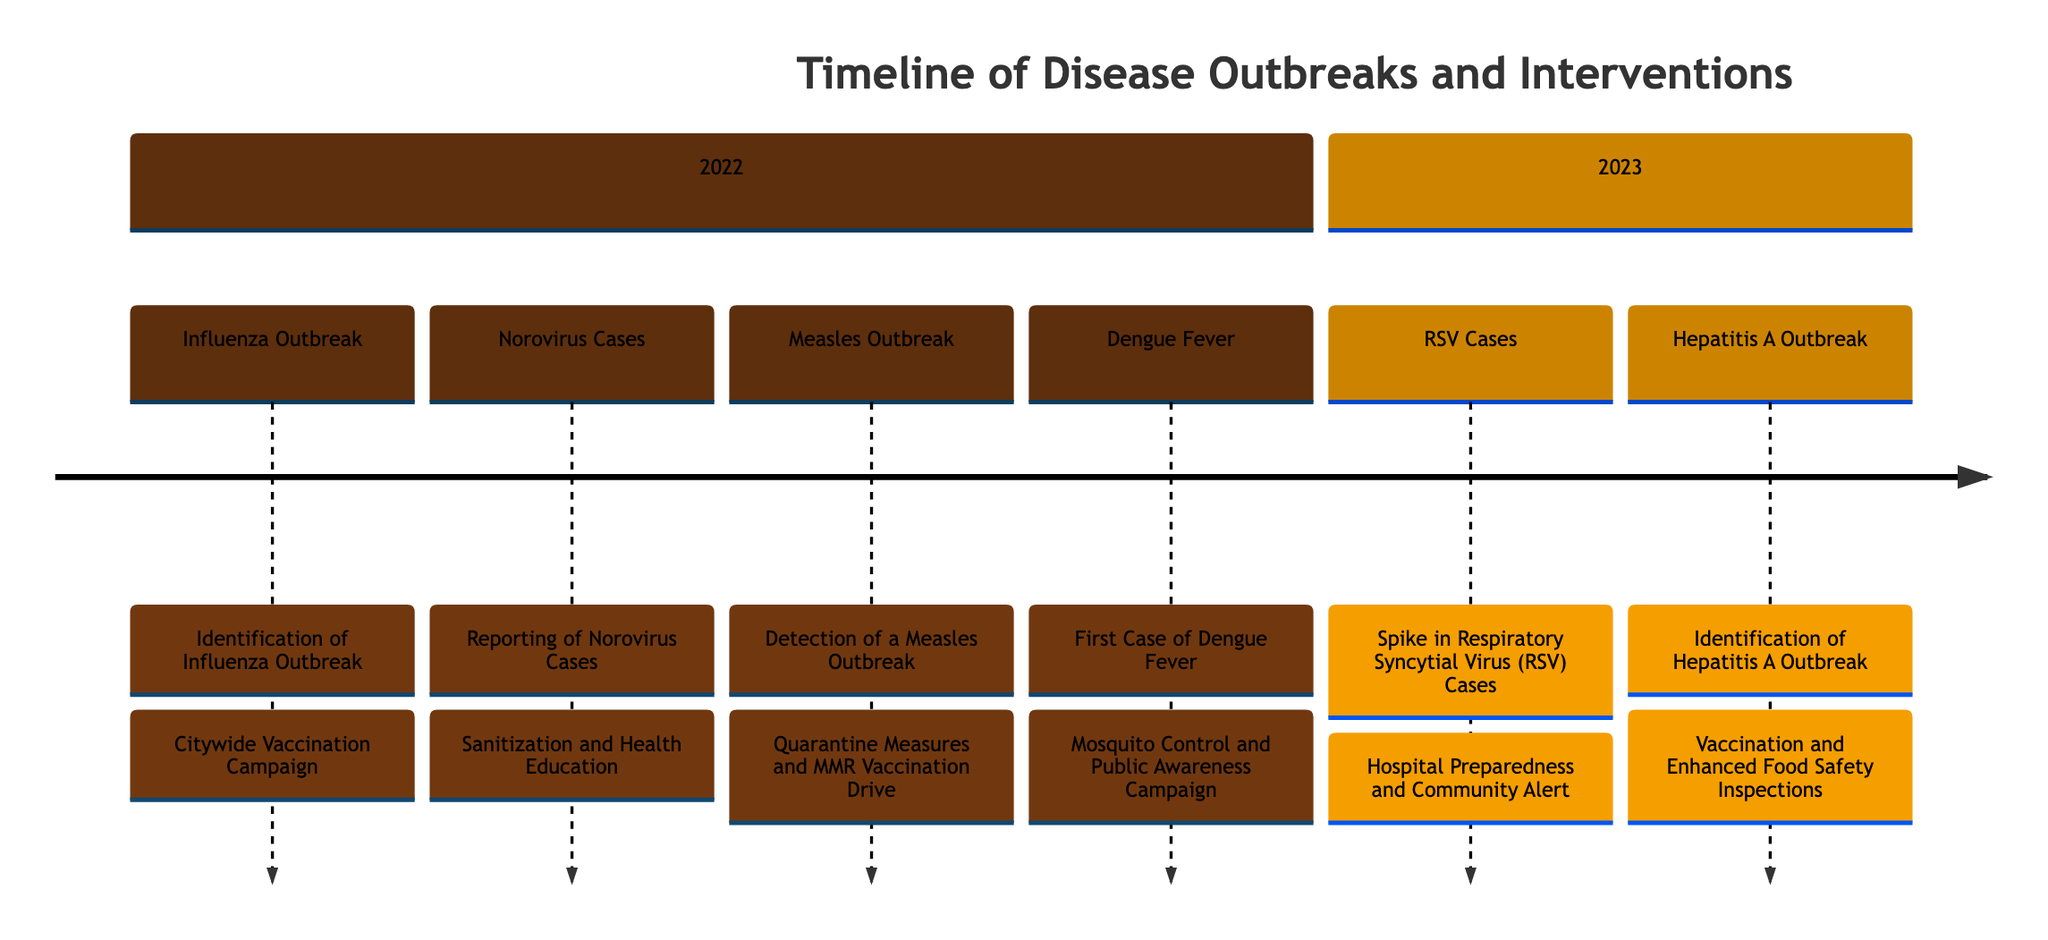What event occurred on January 15, 2022? By looking at the timeline, the event listed for January 15, 2022, is the identification of the influenza outbreak.
Answer: Identification of Influenza Outbreak How many disease outbreak events were reported in 2022? The timeline shows four distinct events listed for the year 2022: Influenza, Norovirus, Measles, and Dengue Fever.
Answer: 4 What intervention was implemented in response to the measles outbreak? For the measles outbreak detected on July 20, 2022, the intervention taken was quarantine measures and an MMR vaccination drive.
Answer: Quarantine Measures and MMR Vaccination Drive When was the first case of dengue fever reported? The timeline states that the first local case of dengue fever was reported on October 12, 2022.
Answer: October 12, 2022 What disease was identified on May 15, 2023? According to the timeline, the disease identified on May 15, 2023, was Hepatitis A.
Answer: Hepatitis A What was the main intervention for the Hepatitis A outbreak? For the Hepatitis A outbreak, the intervention implemented was vaccination and enhanced food safety inspections.
Answer: Vaccination and Enhanced Food Safety Inspections Which outbreak was reported in the local school, and what intervention was taken? The outbreak reported in the local school was Norovirus, and the intervention taken was sanitization and health education.
Answer: Norovirus; Sanitization and Health Education What type of intervention was used for the respiratory syncytial virus cases? The response for RSV cases involved hospital preparedness and a community alert as intervention strategies.
Answer: Hospital Preparedness and Community Alert How many outbreaks were reported in the first half of 2023? The timeline shows two outbreaks were reported in the first half of 2023: RSV and Hepatitis A.
Answer: 2 